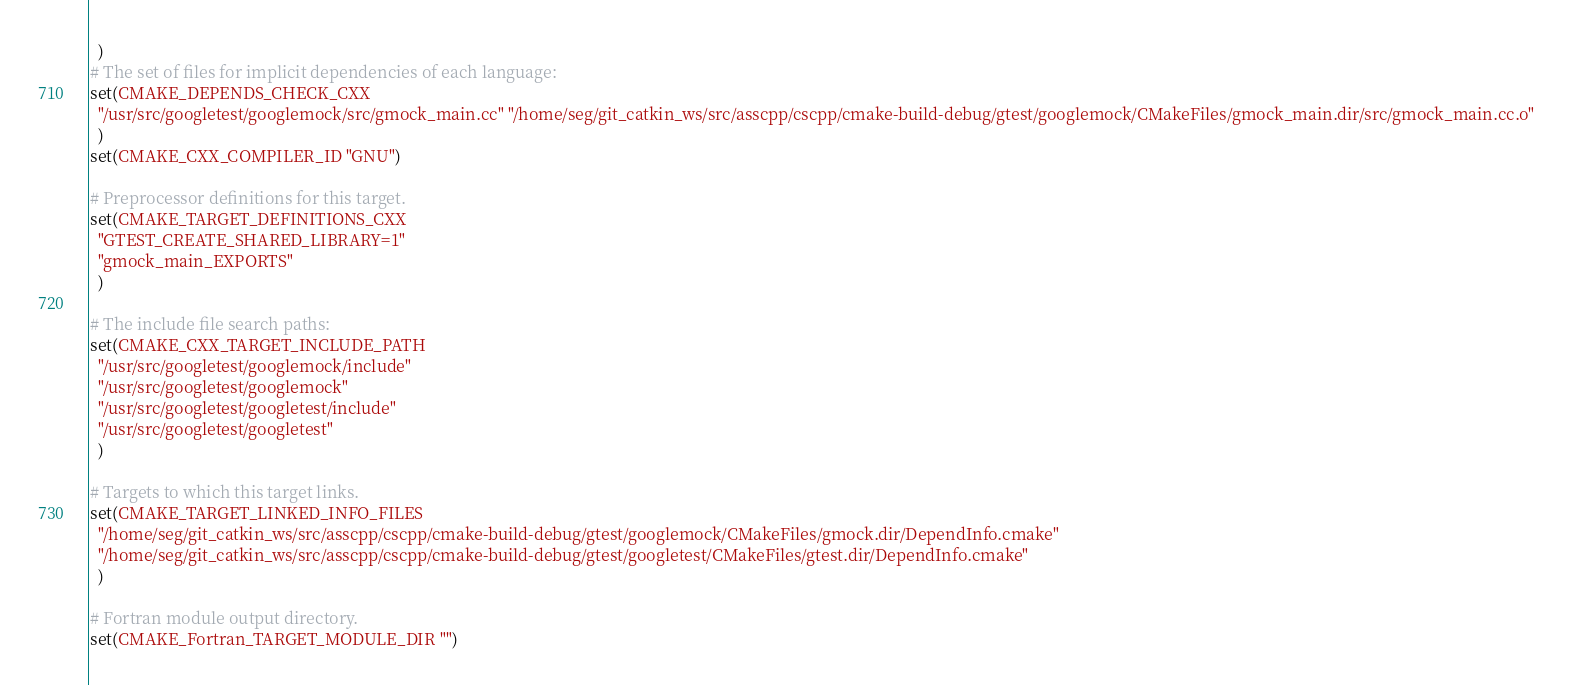Convert code to text. <code><loc_0><loc_0><loc_500><loc_500><_CMake_>  )
# The set of files for implicit dependencies of each language:
set(CMAKE_DEPENDS_CHECK_CXX
  "/usr/src/googletest/googlemock/src/gmock_main.cc" "/home/seg/git_catkin_ws/src/asscpp/cscpp/cmake-build-debug/gtest/googlemock/CMakeFiles/gmock_main.dir/src/gmock_main.cc.o"
  )
set(CMAKE_CXX_COMPILER_ID "GNU")

# Preprocessor definitions for this target.
set(CMAKE_TARGET_DEFINITIONS_CXX
  "GTEST_CREATE_SHARED_LIBRARY=1"
  "gmock_main_EXPORTS"
  )

# The include file search paths:
set(CMAKE_CXX_TARGET_INCLUDE_PATH
  "/usr/src/googletest/googlemock/include"
  "/usr/src/googletest/googlemock"
  "/usr/src/googletest/googletest/include"
  "/usr/src/googletest/googletest"
  )

# Targets to which this target links.
set(CMAKE_TARGET_LINKED_INFO_FILES
  "/home/seg/git_catkin_ws/src/asscpp/cscpp/cmake-build-debug/gtest/googlemock/CMakeFiles/gmock.dir/DependInfo.cmake"
  "/home/seg/git_catkin_ws/src/asscpp/cscpp/cmake-build-debug/gtest/googletest/CMakeFiles/gtest.dir/DependInfo.cmake"
  )

# Fortran module output directory.
set(CMAKE_Fortran_TARGET_MODULE_DIR "")
</code> 